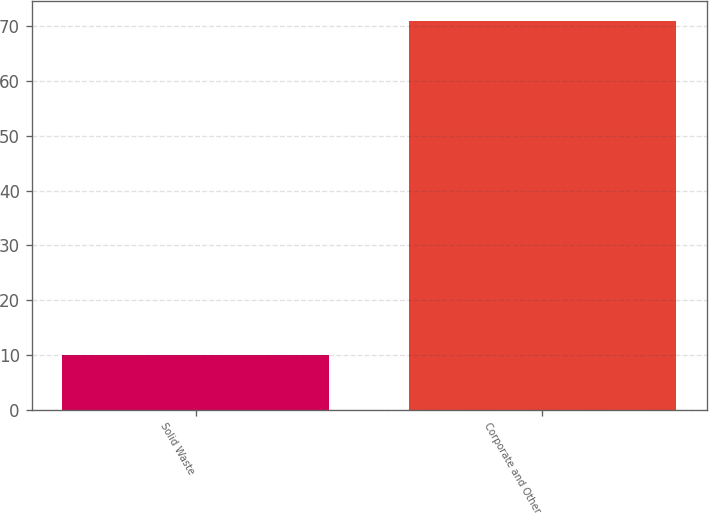<chart> <loc_0><loc_0><loc_500><loc_500><bar_chart><fcel>Solid Waste<fcel>Corporate and Other<nl><fcel>10<fcel>71<nl></chart> 